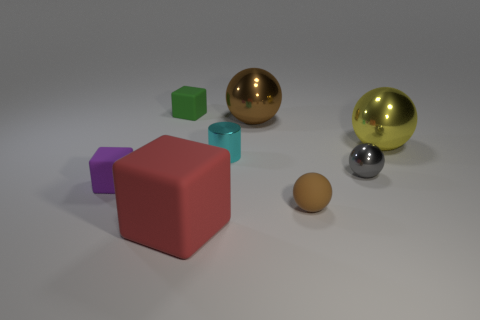Is there anything else that is the same shape as the small cyan metal object?
Your answer should be compact. No. Are there an equal number of tiny brown rubber spheres that are in front of the big matte block and green cylinders?
Ensure brevity in your answer.  Yes. What is the color of the big matte object that is the same shape as the small green rubber object?
Offer a very short reply. Red. What number of tiny purple objects have the same shape as the small brown thing?
Offer a very short reply. 0. What is the material of the other big ball that is the same color as the rubber sphere?
Make the answer very short. Metal. What number of small metallic objects are there?
Your answer should be very brief. 2. Are there any other purple cubes that have the same material as the big cube?
Provide a short and direct response. Yes. What size is the other ball that is the same color as the rubber sphere?
Offer a terse response. Large. Is the size of the cube that is on the right side of the small green block the same as the block that is behind the large brown ball?
Provide a succinct answer. No. What size is the brown object that is in front of the big yellow thing?
Your answer should be compact. Small. 